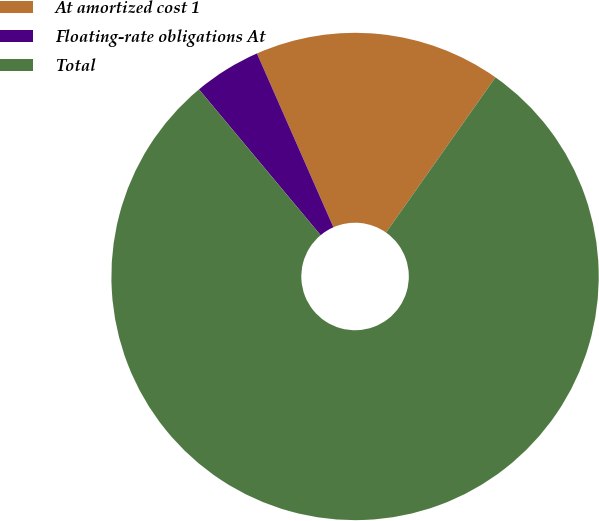Convert chart. <chart><loc_0><loc_0><loc_500><loc_500><pie_chart><fcel>At amortized cost 1<fcel>Floating-rate obligations At<fcel>Total<nl><fcel>16.37%<fcel>4.47%<fcel>79.16%<nl></chart> 